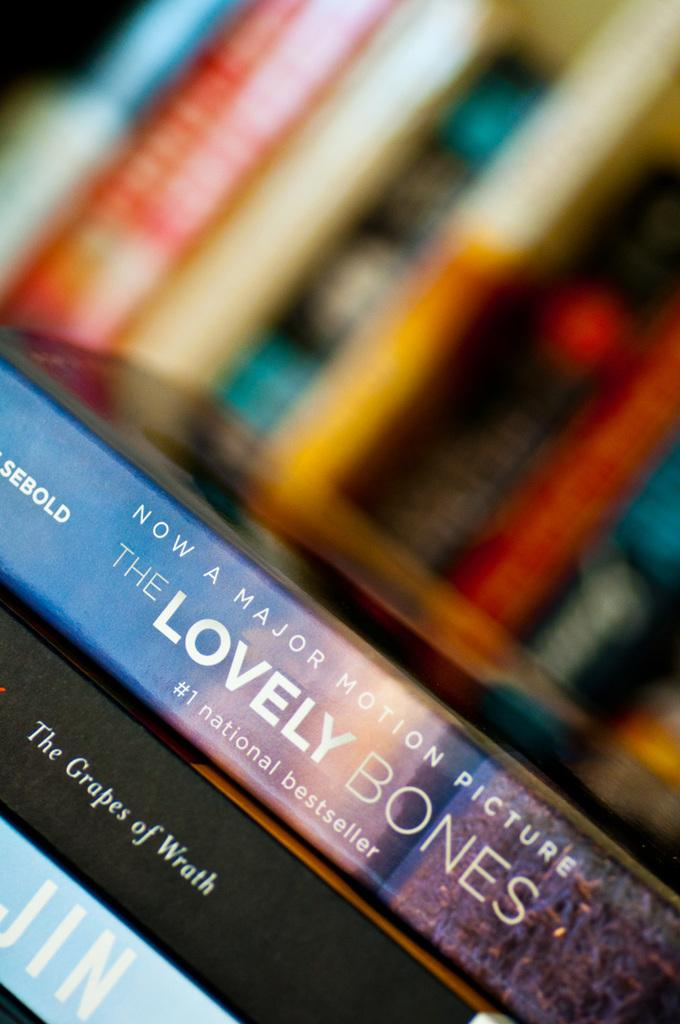<image>
Describe the image concisely. the book called the Lovely Bones on top of other books 